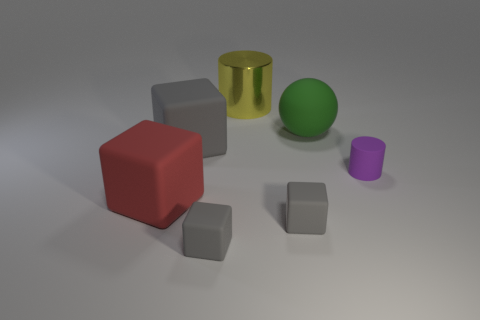The small gray block right of the cylinder behind the green object is made of what material?
Your answer should be very brief. Rubber. What is the shape of the large green matte object?
Your answer should be compact. Sphere. There is a large red object that is the same shape as the large gray matte object; what is its material?
Your response must be concise. Rubber. How many green objects have the same size as the purple cylinder?
Your answer should be compact. 0. Is there a rubber object left of the tiny rubber thing that is to the right of the green matte sphere?
Your response must be concise. Yes. What number of gray objects are tiny rubber cylinders or large matte cubes?
Offer a very short reply. 1. The rubber cylinder is what color?
Ensure brevity in your answer.  Purple. What is the size of the red object that is the same material as the green thing?
Provide a short and direct response. Large. What number of yellow shiny things are the same shape as the big red rubber thing?
Offer a terse response. 0. Are there any other things that are the same size as the purple thing?
Provide a succinct answer. Yes. 